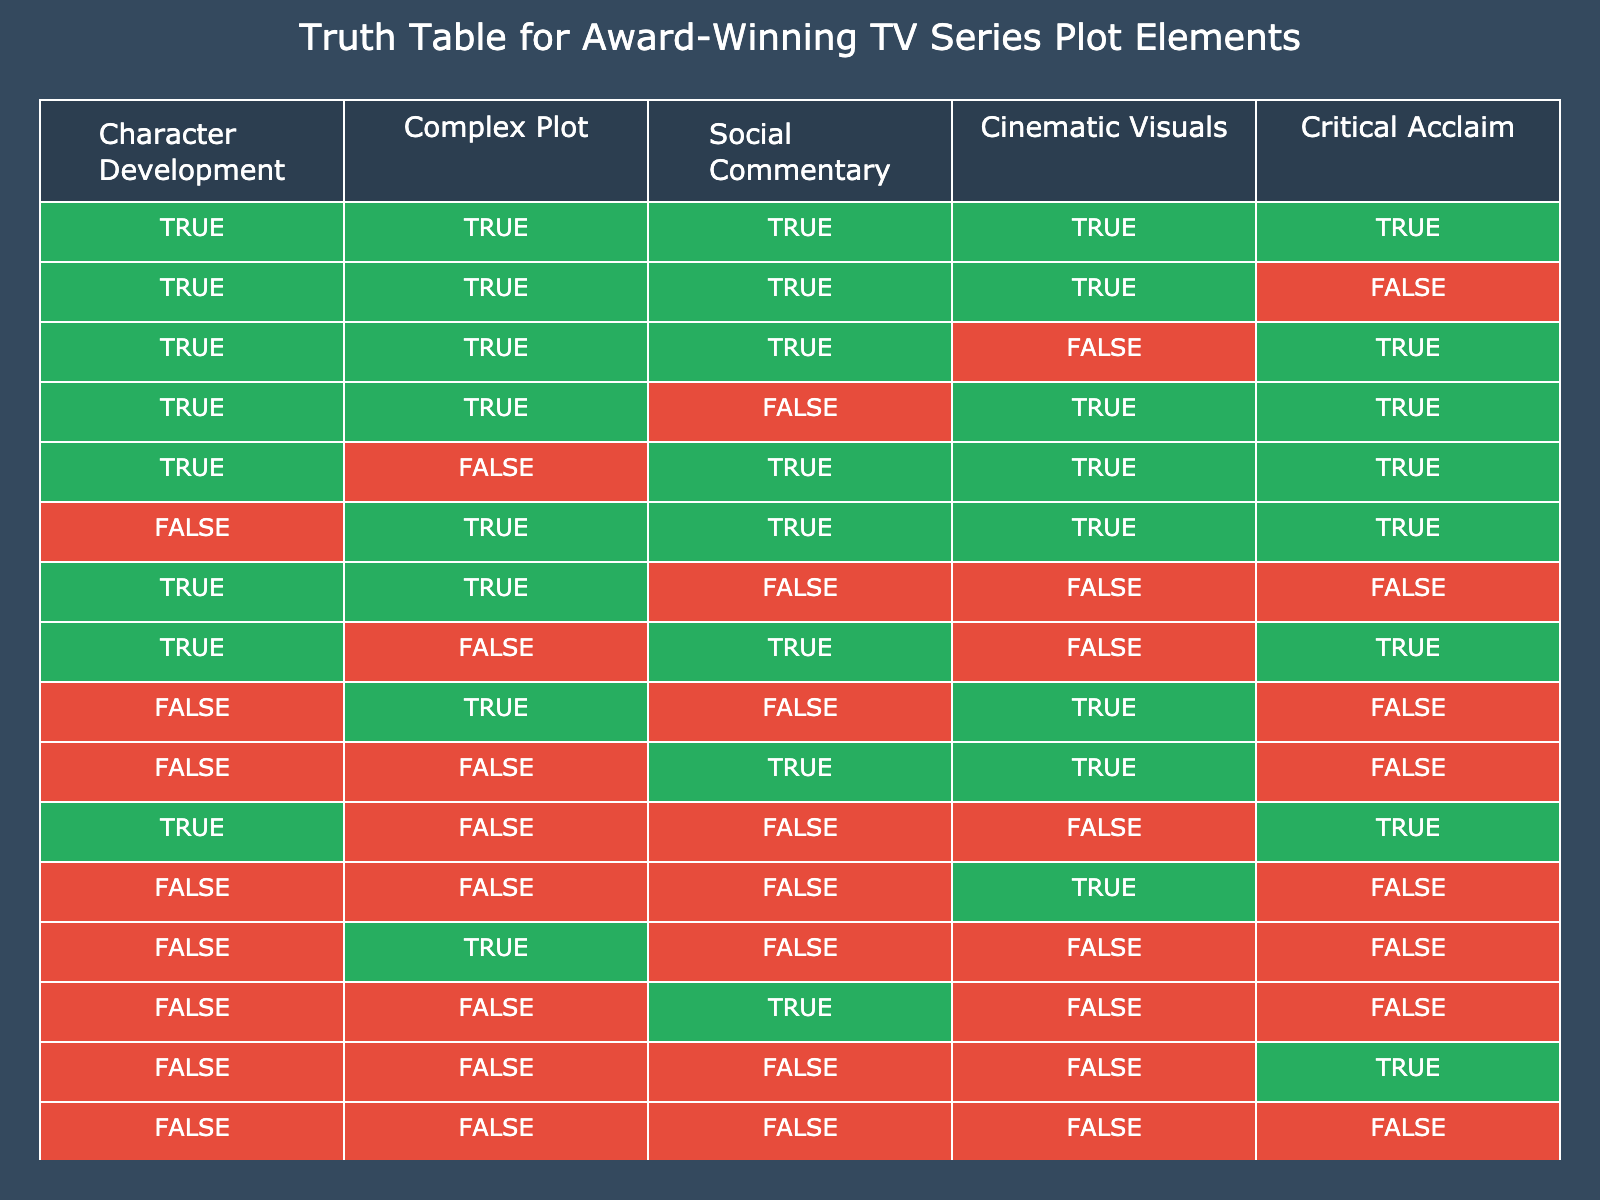What is the total number of plot elements that have critical acclaim as TRUE? By examining the rows in the table, we see that there are 5 instances where Critical Acclaim is TRUE: the first four rows and the last row. Therefore, we can count these rows to find that the total is 5.
Answer: 5 How many plot elements feature both Complex Plot and Cinematic Visuals as TRUE? Looking at the table, there are 3 rows where both Complex Plot and Cinematic Visuals are TRUE: the first row, the second row, and the fifth row. Adding these together gives the total count of these combinations.
Answer: 3 Is it possible for a plot element to have social commentary as TRUE and critical acclaim as FALSE at the same time? Analyzing the table reveals two rows where Social Commentary is TRUE and Critical Acclaim is FALSE: the ninth and tenth rows. This confirms that it is indeed possible for both conditions to be met simultaneously.
Answer: Yes Which plot element appears most frequently with FALSE values across all categories? By checking the table, we note that the combination of FALSE values appears in the last two rows (15th and 16th), where all elements are FALSE. Other rows like the 7th, 12th, and 13th reveal varying combinations. However, the total counts of FALSE across all columns are the highest (8 FALSE occurrences across 5 elements).
Answer: FALSE What proportion of plot elements have both Character Development and Social Commentary as TRUE? To find this, we must first identify the relevant rows. There are 4 rows where both Character Development and Social Commentary are TRUE: first, third, fifth, and sixth rows. The total number of entries is 16, hence the proportions would be 4 out of 16, which simplifies to 1 out of 4.
Answer: 25% 